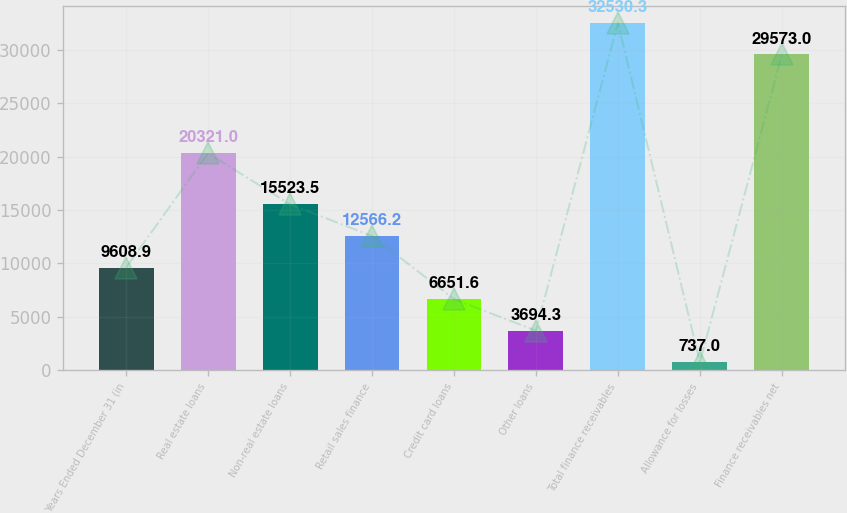Convert chart. <chart><loc_0><loc_0><loc_500><loc_500><bar_chart><fcel>Years Ended December 31 (in<fcel>Real estate loans<fcel>Non-real estate loans<fcel>Retail sales finance<fcel>Credit card loans<fcel>Other loans<fcel>Total finance receivables<fcel>Allowance for losses<fcel>Finance receivables net<nl><fcel>9608.9<fcel>20321<fcel>15523.5<fcel>12566.2<fcel>6651.6<fcel>3694.3<fcel>32530.3<fcel>737<fcel>29573<nl></chart> 